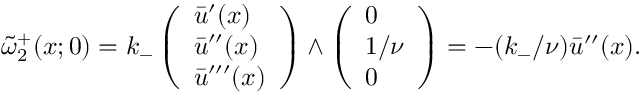Convert formula to latex. <formula><loc_0><loc_0><loc_500><loc_500>\tilde { \omega } _ { 2 } ^ { + } ( x ; 0 ) = k _ { - } \left ( \begin{array} { l } { \bar { u } ^ { \prime } ( x ) } \\ { \bar { u } ^ { \prime \prime } ( x ) } \\ { \bar { u } ^ { \prime \prime \prime } ( x ) } \end{array} \right ) \wedge \left ( \begin{array} { l } { 0 } \\ { 1 / \nu } \\ { 0 } \end{array} \right ) = - ( k _ { - } / \nu ) \bar { u } ^ { \prime \prime } ( x ) .</formula> 